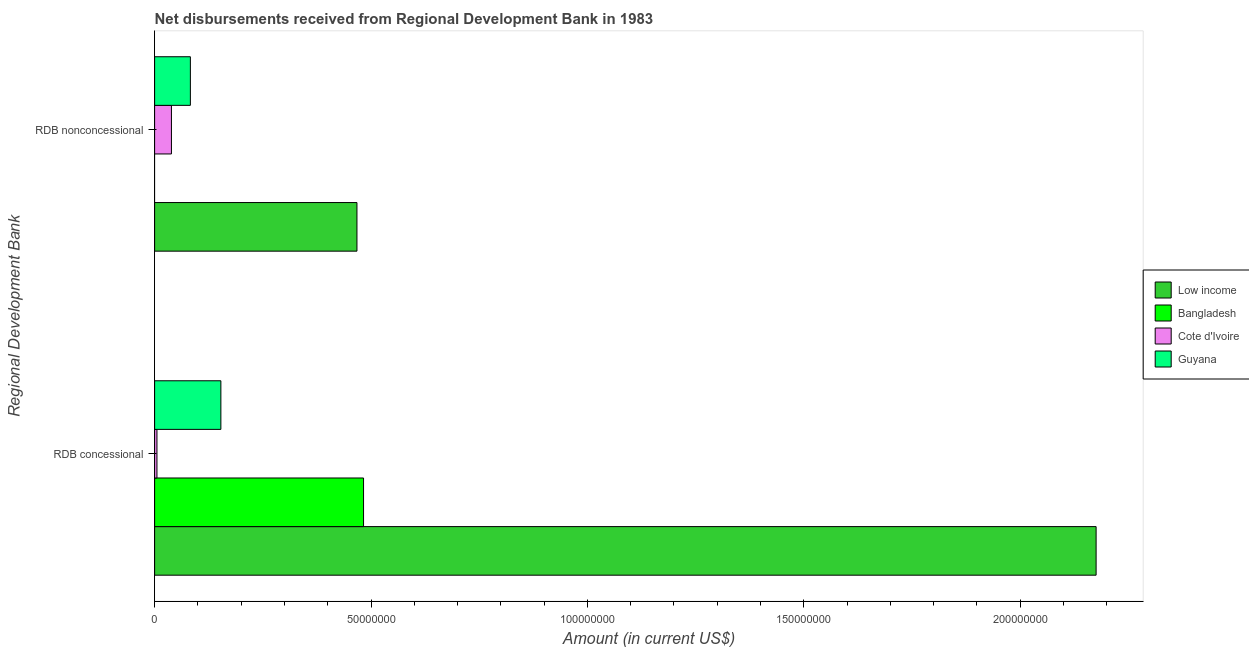How many groups of bars are there?
Provide a succinct answer. 2. How many bars are there on the 2nd tick from the top?
Your response must be concise. 4. What is the label of the 1st group of bars from the top?
Keep it short and to the point. RDB nonconcessional. What is the net concessional disbursements from rdb in Low income?
Give a very brief answer. 2.18e+08. Across all countries, what is the maximum net non concessional disbursements from rdb?
Your response must be concise. 4.68e+07. Across all countries, what is the minimum net non concessional disbursements from rdb?
Keep it short and to the point. 0. What is the total net concessional disbursements from rdb in the graph?
Give a very brief answer. 2.82e+08. What is the difference between the net concessional disbursements from rdb in Low income and that in Bangladesh?
Provide a succinct answer. 1.69e+08. What is the difference between the net concessional disbursements from rdb in Guyana and the net non concessional disbursements from rdb in Cote d'Ivoire?
Provide a short and direct response. 1.14e+07. What is the average net concessional disbursements from rdb per country?
Ensure brevity in your answer.  7.04e+07. What is the difference between the net non concessional disbursements from rdb and net concessional disbursements from rdb in Guyana?
Make the answer very short. -7.05e+06. In how many countries, is the net concessional disbursements from rdb greater than 190000000 US$?
Offer a terse response. 1. What is the ratio of the net concessional disbursements from rdb in Bangladesh to that in Low income?
Your answer should be compact. 0.22. Is the net concessional disbursements from rdb in Bangladesh less than that in Guyana?
Provide a succinct answer. No. How many bars are there?
Offer a very short reply. 7. How many legend labels are there?
Make the answer very short. 4. What is the title of the graph?
Your answer should be very brief. Net disbursements received from Regional Development Bank in 1983. Does "Germany" appear as one of the legend labels in the graph?
Give a very brief answer. No. What is the label or title of the X-axis?
Keep it short and to the point. Amount (in current US$). What is the label or title of the Y-axis?
Give a very brief answer. Regional Development Bank. What is the Amount (in current US$) of Low income in RDB concessional?
Provide a short and direct response. 2.18e+08. What is the Amount (in current US$) in Bangladesh in RDB concessional?
Keep it short and to the point. 4.83e+07. What is the Amount (in current US$) in Cote d'Ivoire in RDB concessional?
Provide a succinct answer. 5.43e+05. What is the Amount (in current US$) of Guyana in RDB concessional?
Your answer should be very brief. 1.53e+07. What is the Amount (in current US$) in Low income in RDB nonconcessional?
Ensure brevity in your answer.  4.68e+07. What is the Amount (in current US$) of Cote d'Ivoire in RDB nonconcessional?
Offer a terse response. 3.89e+06. What is the Amount (in current US$) of Guyana in RDB nonconcessional?
Offer a terse response. 8.26e+06. Across all Regional Development Bank, what is the maximum Amount (in current US$) of Low income?
Provide a succinct answer. 2.18e+08. Across all Regional Development Bank, what is the maximum Amount (in current US$) in Bangladesh?
Give a very brief answer. 4.83e+07. Across all Regional Development Bank, what is the maximum Amount (in current US$) in Cote d'Ivoire?
Keep it short and to the point. 3.89e+06. Across all Regional Development Bank, what is the maximum Amount (in current US$) in Guyana?
Your response must be concise. 1.53e+07. Across all Regional Development Bank, what is the minimum Amount (in current US$) in Low income?
Provide a short and direct response. 4.68e+07. Across all Regional Development Bank, what is the minimum Amount (in current US$) in Cote d'Ivoire?
Provide a succinct answer. 5.43e+05. Across all Regional Development Bank, what is the minimum Amount (in current US$) in Guyana?
Give a very brief answer. 8.26e+06. What is the total Amount (in current US$) of Low income in the graph?
Keep it short and to the point. 2.64e+08. What is the total Amount (in current US$) in Bangladesh in the graph?
Your response must be concise. 4.83e+07. What is the total Amount (in current US$) in Cote d'Ivoire in the graph?
Make the answer very short. 4.43e+06. What is the total Amount (in current US$) in Guyana in the graph?
Provide a succinct answer. 2.36e+07. What is the difference between the Amount (in current US$) in Low income in RDB concessional and that in RDB nonconcessional?
Your answer should be very brief. 1.71e+08. What is the difference between the Amount (in current US$) of Cote d'Ivoire in RDB concessional and that in RDB nonconcessional?
Keep it short and to the point. -3.34e+06. What is the difference between the Amount (in current US$) in Guyana in RDB concessional and that in RDB nonconcessional?
Provide a succinct answer. 7.05e+06. What is the difference between the Amount (in current US$) in Low income in RDB concessional and the Amount (in current US$) in Cote d'Ivoire in RDB nonconcessional?
Offer a very short reply. 2.14e+08. What is the difference between the Amount (in current US$) of Low income in RDB concessional and the Amount (in current US$) of Guyana in RDB nonconcessional?
Offer a very short reply. 2.09e+08. What is the difference between the Amount (in current US$) of Bangladesh in RDB concessional and the Amount (in current US$) of Cote d'Ivoire in RDB nonconcessional?
Provide a succinct answer. 4.44e+07. What is the difference between the Amount (in current US$) of Bangladesh in RDB concessional and the Amount (in current US$) of Guyana in RDB nonconcessional?
Provide a succinct answer. 4.00e+07. What is the difference between the Amount (in current US$) of Cote d'Ivoire in RDB concessional and the Amount (in current US$) of Guyana in RDB nonconcessional?
Make the answer very short. -7.72e+06. What is the average Amount (in current US$) of Low income per Regional Development Bank?
Provide a short and direct response. 1.32e+08. What is the average Amount (in current US$) in Bangladesh per Regional Development Bank?
Provide a short and direct response. 2.41e+07. What is the average Amount (in current US$) in Cote d'Ivoire per Regional Development Bank?
Provide a short and direct response. 2.22e+06. What is the average Amount (in current US$) in Guyana per Regional Development Bank?
Offer a very short reply. 1.18e+07. What is the difference between the Amount (in current US$) of Low income and Amount (in current US$) of Bangladesh in RDB concessional?
Your response must be concise. 1.69e+08. What is the difference between the Amount (in current US$) of Low income and Amount (in current US$) of Cote d'Ivoire in RDB concessional?
Ensure brevity in your answer.  2.17e+08. What is the difference between the Amount (in current US$) of Low income and Amount (in current US$) of Guyana in RDB concessional?
Your response must be concise. 2.02e+08. What is the difference between the Amount (in current US$) of Bangladesh and Amount (in current US$) of Cote d'Ivoire in RDB concessional?
Your answer should be compact. 4.77e+07. What is the difference between the Amount (in current US$) of Bangladesh and Amount (in current US$) of Guyana in RDB concessional?
Make the answer very short. 3.30e+07. What is the difference between the Amount (in current US$) of Cote d'Ivoire and Amount (in current US$) of Guyana in RDB concessional?
Ensure brevity in your answer.  -1.48e+07. What is the difference between the Amount (in current US$) of Low income and Amount (in current US$) of Cote d'Ivoire in RDB nonconcessional?
Provide a short and direct response. 4.29e+07. What is the difference between the Amount (in current US$) in Low income and Amount (in current US$) in Guyana in RDB nonconcessional?
Give a very brief answer. 3.85e+07. What is the difference between the Amount (in current US$) in Cote d'Ivoire and Amount (in current US$) in Guyana in RDB nonconcessional?
Keep it short and to the point. -4.38e+06. What is the ratio of the Amount (in current US$) in Low income in RDB concessional to that in RDB nonconcessional?
Keep it short and to the point. 4.65. What is the ratio of the Amount (in current US$) in Cote d'Ivoire in RDB concessional to that in RDB nonconcessional?
Give a very brief answer. 0.14. What is the ratio of the Amount (in current US$) of Guyana in RDB concessional to that in RDB nonconcessional?
Your response must be concise. 1.85. What is the difference between the highest and the second highest Amount (in current US$) in Low income?
Your answer should be compact. 1.71e+08. What is the difference between the highest and the second highest Amount (in current US$) of Cote d'Ivoire?
Your answer should be compact. 3.34e+06. What is the difference between the highest and the second highest Amount (in current US$) of Guyana?
Your response must be concise. 7.05e+06. What is the difference between the highest and the lowest Amount (in current US$) of Low income?
Provide a succinct answer. 1.71e+08. What is the difference between the highest and the lowest Amount (in current US$) in Bangladesh?
Keep it short and to the point. 4.83e+07. What is the difference between the highest and the lowest Amount (in current US$) of Cote d'Ivoire?
Offer a terse response. 3.34e+06. What is the difference between the highest and the lowest Amount (in current US$) in Guyana?
Provide a succinct answer. 7.05e+06. 